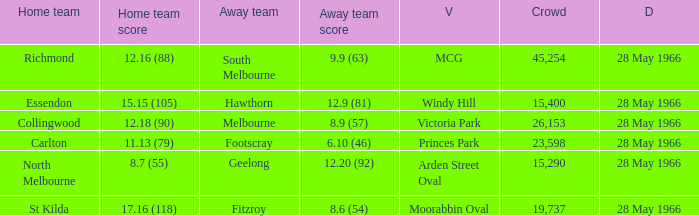Write the full table. {'header': ['Home team', 'Home team score', 'Away team', 'Away team score', 'V', 'Crowd', 'D'], 'rows': [['Richmond', '12.16 (88)', 'South Melbourne', '9.9 (63)', 'MCG', '45,254', '28 May 1966'], ['Essendon', '15.15 (105)', 'Hawthorn', '12.9 (81)', 'Windy Hill', '15,400', '28 May 1966'], ['Collingwood', '12.18 (90)', 'Melbourne', '8.9 (57)', 'Victoria Park', '26,153', '28 May 1966'], ['Carlton', '11.13 (79)', 'Footscray', '6.10 (46)', 'Princes Park', '23,598', '28 May 1966'], ['North Melbourne', '8.7 (55)', 'Geelong', '12.20 (92)', 'Arden Street Oval', '15,290', '28 May 1966'], ['St Kilda', '17.16 (118)', 'Fitzroy', '8.6 (54)', 'Moorabbin Oval', '19,737', '28 May 1966']]} Which Crowd has a Home team of richmond? 45254.0. 